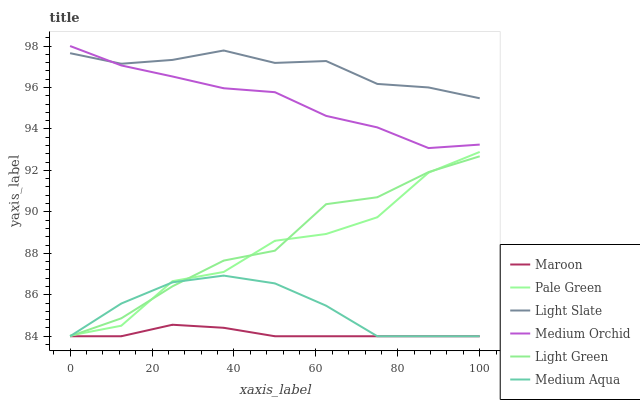Does Maroon have the minimum area under the curve?
Answer yes or no. Yes. Does Light Slate have the maximum area under the curve?
Answer yes or no. Yes. Does Medium Orchid have the minimum area under the curve?
Answer yes or no. No. Does Medium Orchid have the maximum area under the curve?
Answer yes or no. No. Is Maroon the smoothest?
Answer yes or no. Yes. Is Pale Green the roughest?
Answer yes or no. Yes. Is Medium Orchid the smoothest?
Answer yes or no. No. Is Medium Orchid the roughest?
Answer yes or no. No. Does Maroon have the lowest value?
Answer yes or no. Yes. Does Medium Orchid have the lowest value?
Answer yes or no. No. Does Medium Orchid have the highest value?
Answer yes or no. Yes. Does Maroon have the highest value?
Answer yes or no. No. Is Maroon less than Light Slate?
Answer yes or no. Yes. Is Medium Orchid greater than Light Green?
Answer yes or no. Yes. Does Maroon intersect Medium Aqua?
Answer yes or no. Yes. Is Maroon less than Medium Aqua?
Answer yes or no. No. Is Maroon greater than Medium Aqua?
Answer yes or no. No. Does Maroon intersect Light Slate?
Answer yes or no. No. 